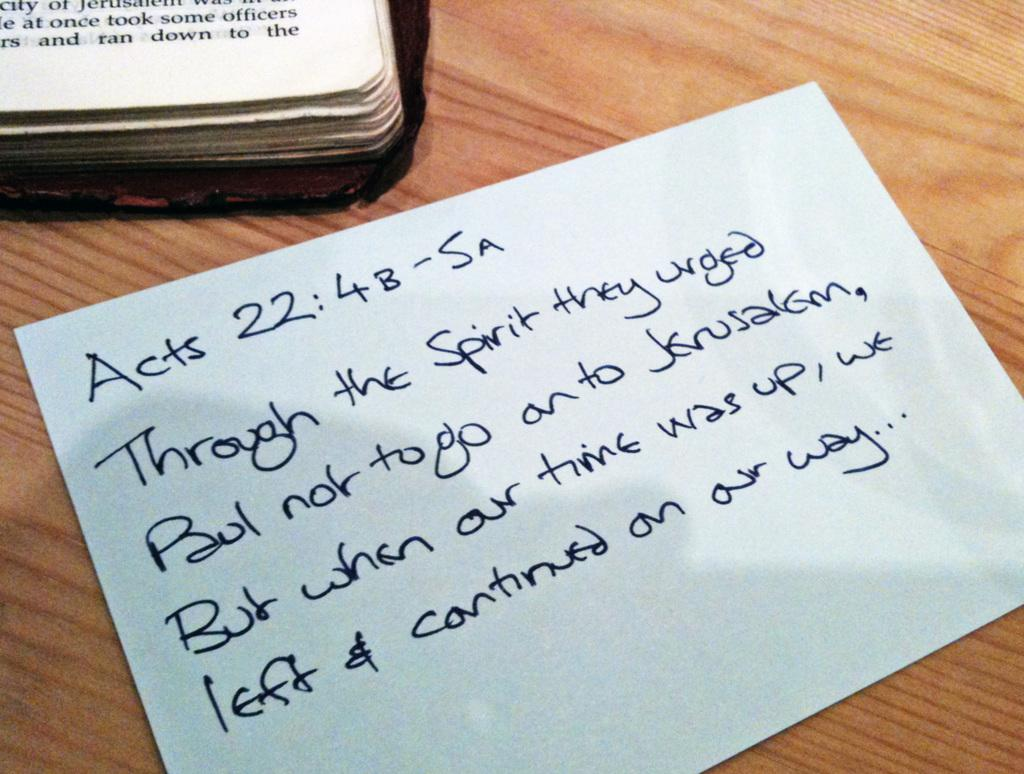<image>
Relay a brief, clear account of the picture shown. A white note begins with the label Acts 22:4B-SA. 